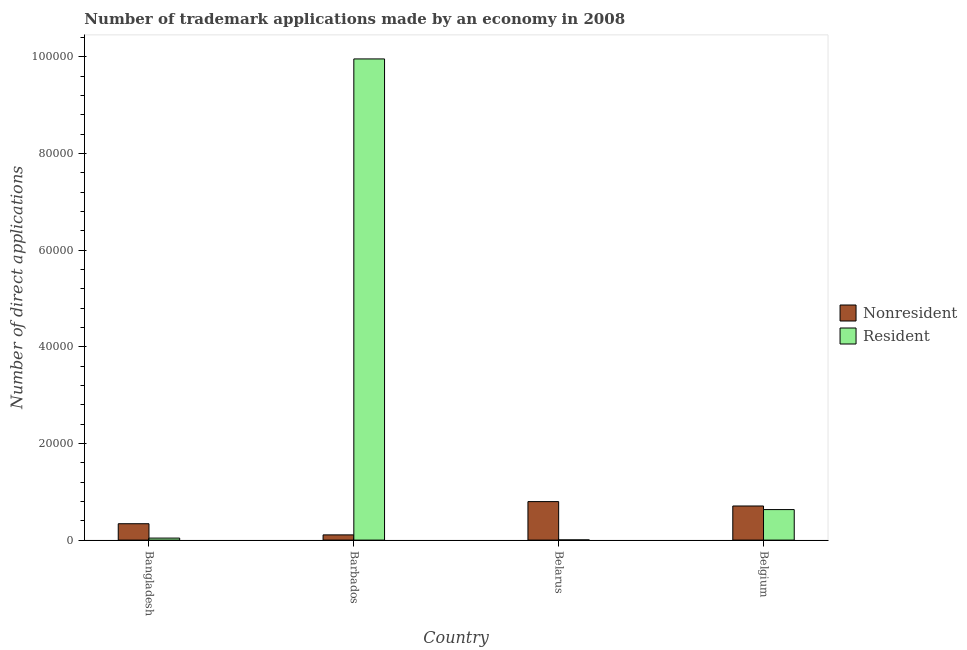How many different coloured bars are there?
Your answer should be very brief. 2. How many groups of bars are there?
Your answer should be very brief. 4. Are the number of bars on each tick of the X-axis equal?
Offer a very short reply. Yes. What is the label of the 2nd group of bars from the left?
Offer a terse response. Barbados. In how many cases, is the number of bars for a given country not equal to the number of legend labels?
Give a very brief answer. 0. What is the number of trademark applications made by residents in Belgium?
Give a very brief answer. 6315. Across all countries, what is the maximum number of trademark applications made by residents?
Offer a terse response. 9.96e+04. Across all countries, what is the minimum number of trademark applications made by non residents?
Make the answer very short. 1079. In which country was the number of trademark applications made by residents maximum?
Provide a succinct answer. Barbados. In which country was the number of trademark applications made by residents minimum?
Your answer should be compact. Belarus. What is the total number of trademark applications made by residents in the graph?
Offer a very short reply. 1.06e+05. What is the difference between the number of trademark applications made by non residents in Barbados and that in Belgium?
Offer a very short reply. -5980. What is the difference between the number of trademark applications made by residents in Bangladesh and the number of trademark applications made by non residents in Belgium?
Keep it short and to the point. -6643. What is the average number of trademark applications made by non residents per country?
Your response must be concise. 4873.25. What is the difference between the number of trademark applications made by non residents and number of trademark applications made by residents in Barbados?
Make the answer very short. -9.85e+04. What is the ratio of the number of trademark applications made by non residents in Belarus to that in Belgium?
Provide a succinct answer. 1.13. Is the number of trademark applications made by non residents in Bangladesh less than that in Belarus?
Make the answer very short. Yes. Is the difference between the number of trademark applications made by non residents in Bangladesh and Belgium greater than the difference between the number of trademark applications made by residents in Bangladesh and Belgium?
Provide a short and direct response. Yes. What is the difference between the highest and the second highest number of trademark applications made by non residents?
Provide a short and direct response. 908. What is the difference between the highest and the lowest number of trademark applications made by non residents?
Your answer should be compact. 6888. What does the 1st bar from the left in Belgium represents?
Provide a succinct answer. Nonresident. What does the 2nd bar from the right in Bangladesh represents?
Offer a terse response. Nonresident. How many bars are there?
Your answer should be very brief. 8. How many countries are there in the graph?
Offer a terse response. 4. Does the graph contain any zero values?
Ensure brevity in your answer.  No. Does the graph contain grids?
Offer a very short reply. No. How many legend labels are there?
Make the answer very short. 2. What is the title of the graph?
Your answer should be compact. Number of trademark applications made by an economy in 2008. What is the label or title of the X-axis?
Keep it short and to the point. Country. What is the label or title of the Y-axis?
Offer a very short reply. Number of direct applications. What is the Number of direct applications in Nonresident in Bangladesh?
Offer a very short reply. 3388. What is the Number of direct applications of Resident in Bangladesh?
Make the answer very short. 416. What is the Number of direct applications of Nonresident in Barbados?
Offer a very short reply. 1079. What is the Number of direct applications in Resident in Barbados?
Ensure brevity in your answer.  9.96e+04. What is the Number of direct applications of Nonresident in Belarus?
Your answer should be very brief. 7967. What is the Number of direct applications of Nonresident in Belgium?
Your answer should be very brief. 7059. What is the Number of direct applications in Resident in Belgium?
Offer a very short reply. 6315. Across all countries, what is the maximum Number of direct applications of Nonresident?
Make the answer very short. 7967. Across all countries, what is the maximum Number of direct applications of Resident?
Your response must be concise. 9.96e+04. Across all countries, what is the minimum Number of direct applications of Nonresident?
Offer a terse response. 1079. Across all countries, what is the minimum Number of direct applications in Resident?
Make the answer very short. 40. What is the total Number of direct applications of Nonresident in the graph?
Your response must be concise. 1.95e+04. What is the total Number of direct applications of Resident in the graph?
Your answer should be compact. 1.06e+05. What is the difference between the Number of direct applications of Nonresident in Bangladesh and that in Barbados?
Provide a succinct answer. 2309. What is the difference between the Number of direct applications in Resident in Bangladesh and that in Barbados?
Provide a succinct answer. -9.92e+04. What is the difference between the Number of direct applications in Nonresident in Bangladesh and that in Belarus?
Provide a succinct answer. -4579. What is the difference between the Number of direct applications in Resident in Bangladesh and that in Belarus?
Offer a very short reply. 376. What is the difference between the Number of direct applications of Nonresident in Bangladesh and that in Belgium?
Give a very brief answer. -3671. What is the difference between the Number of direct applications of Resident in Bangladesh and that in Belgium?
Your answer should be very brief. -5899. What is the difference between the Number of direct applications in Nonresident in Barbados and that in Belarus?
Give a very brief answer. -6888. What is the difference between the Number of direct applications in Resident in Barbados and that in Belarus?
Offer a very short reply. 9.95e+04. What is the difference between the Number of direct applications of Nonresident in Barbados and that in Belgium?
Ensure brevity in your answer.  -5980. What is the difference between the Number of direct applications of Resident in Barbados and that in Belgium?
Ensure brevity in your answer.  9.33e+04. What is the difference between the Number of direct applications in Nonresident in Belarus and that in Belgium?
Provide a short and direct response. 908. What is the difference between the Number of direct applications of Resident in Belarus and that in Belgium?
Ensure brevity in your answer.  -6275. What is the difference between the Number of direct applications in Nonresident in Bangladesh and the Number of direct applications in Resident in Barbados?
Give a very brief answer. -9.62e+04. What is the difference between the Number of direct applications of Nonresident in Bangladesh and the Number of direct applications of Resident in Belarus?
Keep it short and to the point. 3348. What is the difference between the Number of direct applications in Nonresident in Bangladesh and the Number of direct applications in Resident in Belgium?
Make the answer very short. -2927. What is the difference between the Number of direct applications of Nonresident in Barbados and the Number of direct applications of Resident in Belarus?
Offer a terse response. 1039. What is the difference between the Number of direct applications in Nonresident in Barbados and the Number of direct applications in Resident in Belgium?
Provide a short and direct response. -5236. What is the difference between the Number of direct applications of Nonresident in Belarus and the Number of direct applications of Resident in Belgium?
Your answer should be very brief. 1652. What is the average Number of direct applications of Nonresident per country?
Your response must be concise. 4873.25. What is the average Number of direct applications in Resident per country?
Provide a succinct answer. 2.66e+04. What is the difference between the Number of direct applications of Nonresident and Number of direct applications of Resident in Bangladesh?
Offer a very short reply. 2972. What is the difference between the Number of direct applications of Nonresident and Number of direct applications of Resident in Barbados?
Offer a very short reply. -9.85e+04. What is the difference between the Number of direct applications in Nonresident and Number of direct applications in Resident in Belarus?
Give a very brief answer. 7927. What is the difference between the Number of direct applications in Nonresident and Number of direct applications in Resident in Belgium?
Provide a short and direct response. 744. What is the ratio of the Number of direct applications in Nonresident in Bangladesh to that in Barbados?
Your answer should be compact. 3.14. What is the ratio of the Number of direct applications of Resident in Bangladesh to that in Barbados?
Offer a very short reply. 0. What is the ratio of the Number of direct applications in Nonresident in Bangladesh to that in Belarus?
Make the answer very short. 0.43. What is the ratio of the Number of direct applications of Nonresident in Bangladesh to that in Belgium?
Your response must be concise. 0.48. What is the ratio of the Number of direct applications of Resident in Bangladesh to that in Belgium?
Keep it short and to the point. 0.07. What is the ratio of the Number of direct applications in Nonresident in Barbados to that in Belarus?
Give a very brief answer. 0.14. What is the ratio of the Number of direct applications of Resident in Barbados to that in Belarus?
Offer a very short reply. 2489.25. What is the ratio of the Number of direct applications in Nonresident in Barbados to that in Belgium?
Keep it short and to the point. 0.15. What is the ratio of the Number of direct applications in Resident in Barbados to that in Belgium?
Provide a short and direct response. 15.77. What is the ratio of the Number of direct applications of Nonresident in Belarus to that in Belgium?
Provide a short and direct response. 1.13. What is the ratio of the Number of direct applications in Resident in Belarus to that in Belgium?
Give a very brief answer. 0.01. What is the difference between the highest and the second highest Number of direct applications of Nonresident?
Offer a very short reply. 908. What is the difference between the highest and the second highest Number of direct applications in Resident?
Your response must be concise. 9.33e+04. What is the difference between the highest and the lowest Number of direct applications in Nonresident?
Your answer should be compact. 6888. What is the difference between the highest and the lowest Number of direct applications of Resident?
Ensure brevity in your answer.  9.95e+04. 